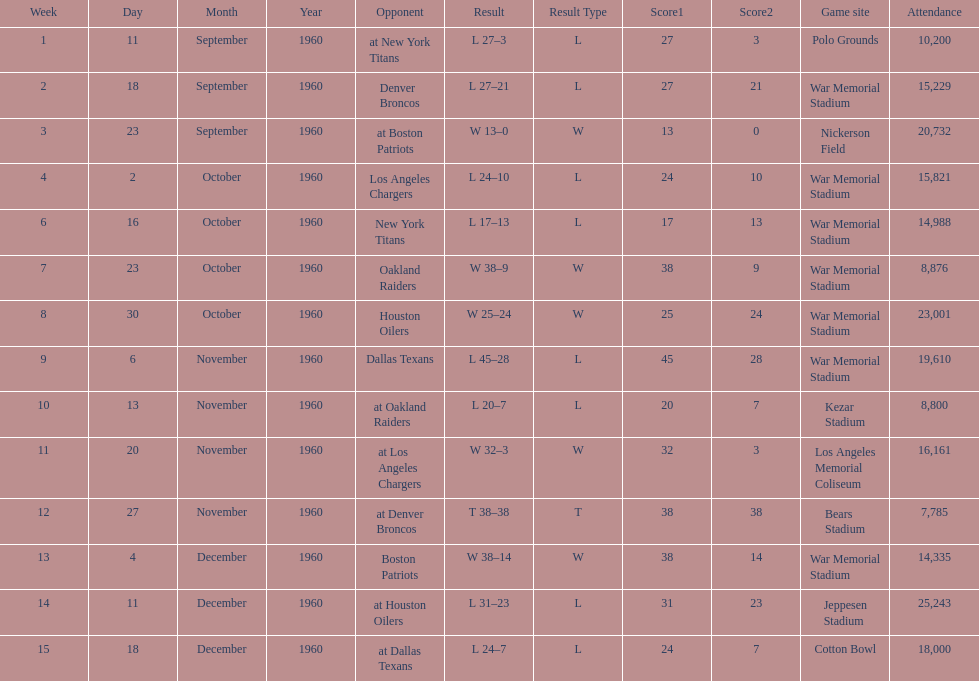Which date had the highest attendance? December 11, 1960. 